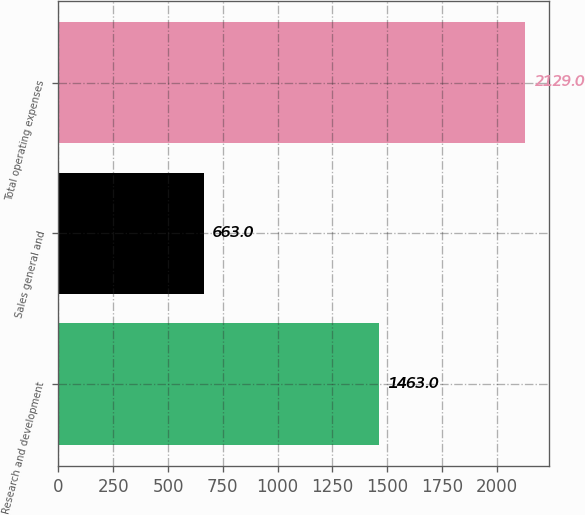<chart> <loc_0><loc_0><loc_500><loc_500><bar_chart><fcel>Research and development<fcel>Sales general and<fcel>Total operating expenses<nl><fcel>1463<fcel>663<fcel>2129<nl></chart> 